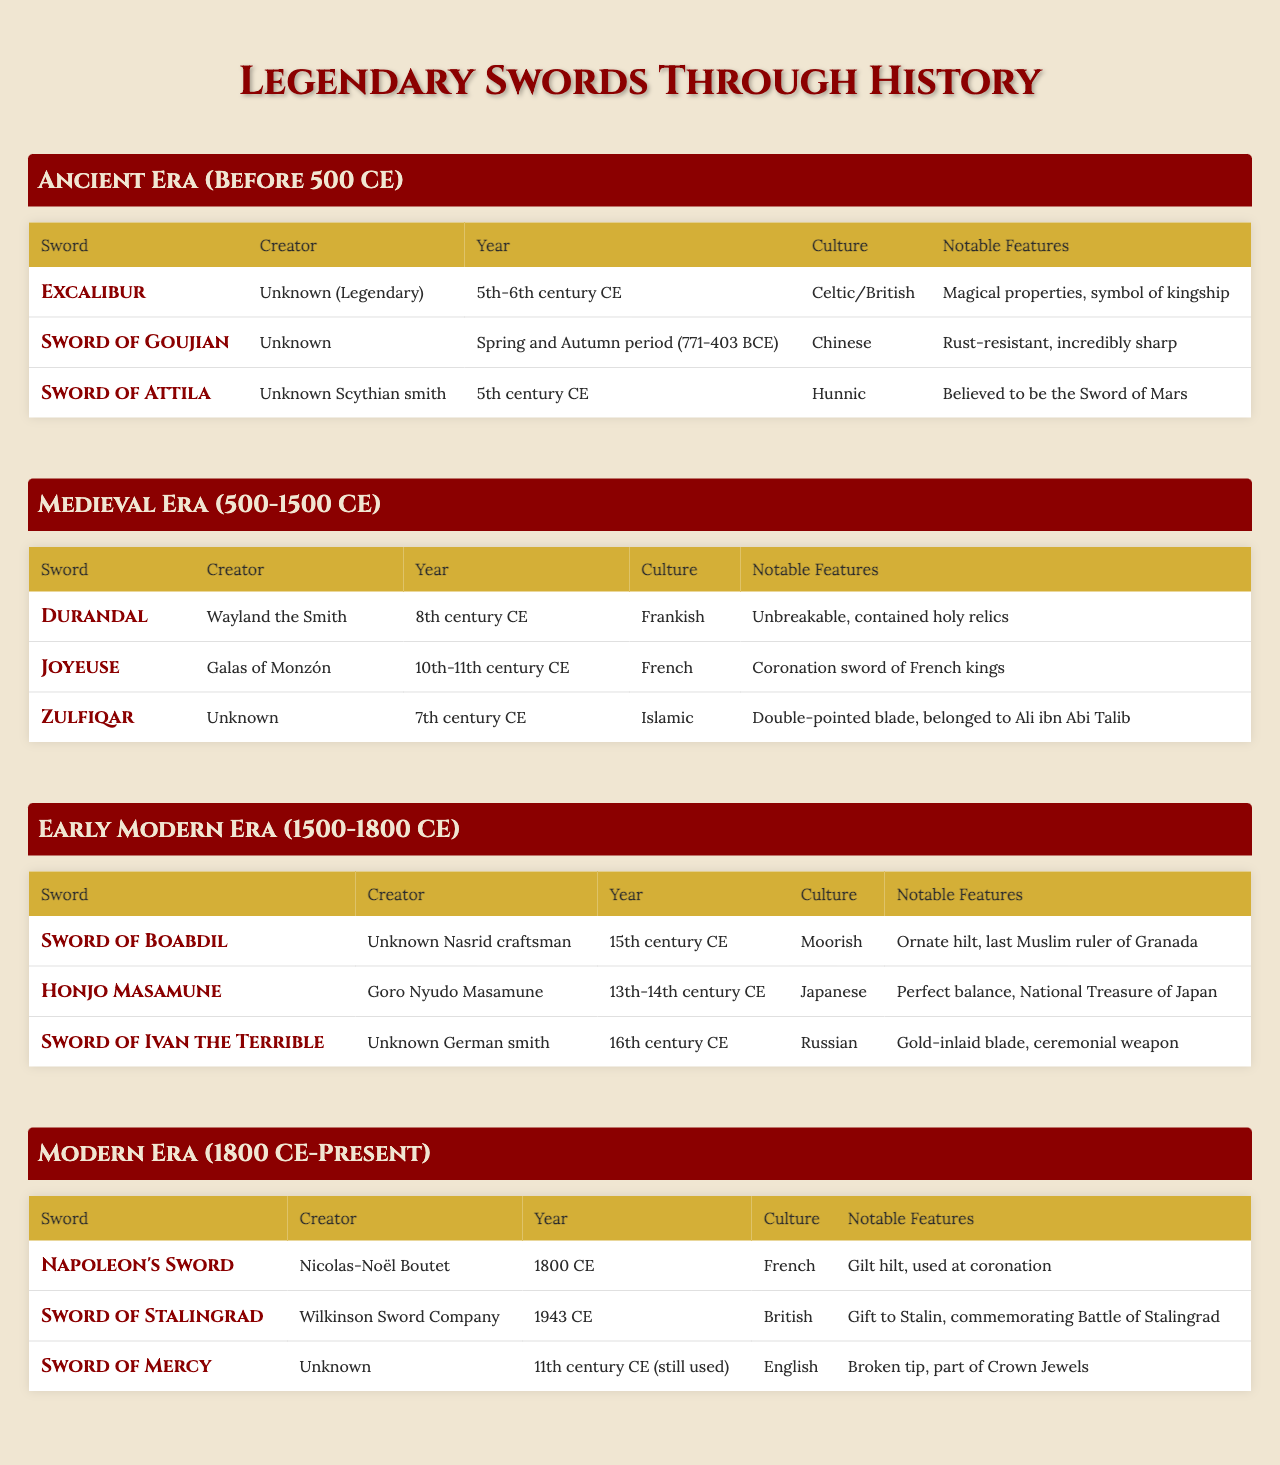What legendary sword was created by Wayland the Smith? Looking at the Medieval Era section of the table, the sword crafted by Wayland the Smith is Durandal.
Answer: Durandal Which culture does the Sword of Goujian belong to? The Sword of Goujian is listed under the Ancient Era, and its culture is identified as Chinese.
Answer: Chinese Did the sword Zulfiqar have a single-pointed blade? The notable features of Zulfiqar mention it has a double-pointed blade, thus the statement is false.
Answer: No What year was Napoleon's Sword made compared to the Sword of Stalingrad? Napoleon's Sword was made in 1800, while the Sword of Stalingrad was created in 1943. Since 1943 is after 1800, we conclude that the Sword of Stalingrad was created later.
Answer: Later Who is the creator of the Honjo Masamune? The table states that the Honjo Masamune was created by Goro Nyudo Masamune.
Answer: Goro Nyudo Masamune Which sword has the notable feature of having "magical properties"? The sword with magical properties is Excalibur, as indicated in the Ancient Era section.
Answer: Excalibur How many swords listed in the table were created in the 11th century? By checking the years listed, we find that the Sword of Mercy is from the 11th century, while another sword from that century doesn't exist in the data; therefore, the total is one.
Answer: One Which era features the creator named "Galas of Monzón"? Referring to the Medieval Era, the creator named Galas of Monzón is linked to the sword Joyeuse.
Answer: Medieval Era Does the Sword of Ivan the Terrible have any notable features that mention gold? The Sword of Ivan the Terrible is noted for its gold-inlaid blade as a distinctive feature.
Answer: Yes Which sword has the latest creation year according to the table? The Sword of Stalingrad has the latest creation year of 1943, which is after all other swords listed.
Answer: Sword of Stalingrad 